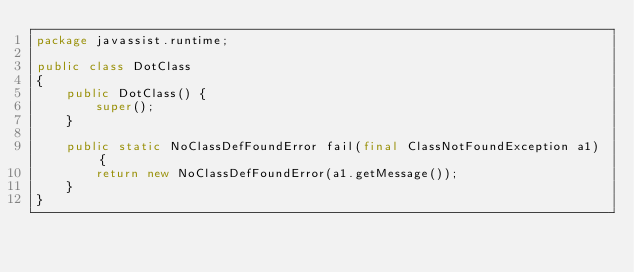Convert code to text. <code><loc_0><loc_0><loc_500><loc_500><_Java_>package javassist.runtime;

public class DotClass
{
    public DotClass() {
        super();
    }
    
    public static NoClassDefFoundError fail(final ClassNotFoundException a1) {
        return new NoClassDefFoundError(a1.getMessage());
    }
}
</code> 